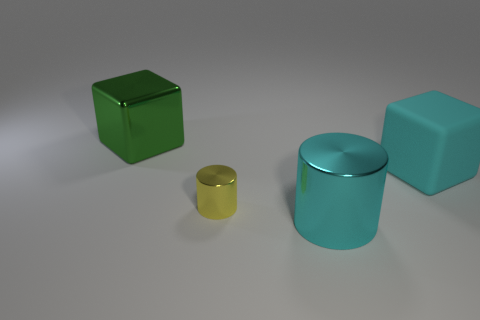Is the yellow cylinder made of the same material as the block that is right of the small metallic cylinder? It is not possible to accurately determine the materials of objects in the image without additional context or information. However, visually, the yellow cylinder has a different surface texture and color compared to the block to its right, suggesting they could be made from different materials. 